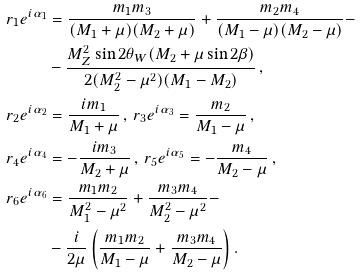Convert formula to latex. <formula><loc_0><loc_0><loc_500><loc_500>r _ { 1 } e ^ { i \alpha _ { 1 } } & = \frac { m _ { 1 } m _ { 3 } } { ( M _ { 1 } + \mu ) ( M _ { 2 } + \mu ) } + \frac { m _ { 2 } m _ { 4 } } { ( M _ { 1 } - \mu ) ( M _ { 2 } - \mu ) } - \\ & - \frac { M ^ { 2 } _ { Z } \sin 2 \theta _ { W } ( M _ { 2 } + \mu \sin 2 \beta ) } { 2 ( M ^ { 2 } _ { 2 } - \mu ^ { 2 } ) ( M _ { 1 } - M _ { 2 } ) } \, , \\ r _ { 2 } e ^ { i \alpha _ { 2 } } & = \frac { i m _ { 1 } } { M _ { 1 } + \mu } \, , \, r _ { 3 } e ^ { i \alpha _ { 3 } } = \frac { m _ { 2 } } { M _ { 1 } - \mu } \, , \\ r _ { 4 } e ^ { i \alpha _ { 4 } } & = - \frac { i m _ { 3 } } { M _ { 2 } + \mu } \, , \, r _ { 5 } e ^ { i \alpha _ { 5 } } = - \frac { m _ { 4 } } { M _ { 2 } - \mu } \, , \\ r _ { 6 } e ^ { i \alpha _ { 6 } } & = \frac { m _ { 1 } m _ { 2 } } { M ^ { 2 } _ { 1 } - \mu ^ { 2 } } + \frac { m _ { 3 } m _ { 4 } } { M ^ { 2 } _ { 2 } - \mu ^ { 2 } } - \\ & - \frac { i } { 2 \mu } \left ( \frac { m _ { 1 } m _ { 2 } } { M _ { 1 } - \mu } + \frac { m _ { 3 } m _ { 4 } } { M _ { 2 } - \mu } \right ) .</formula> 